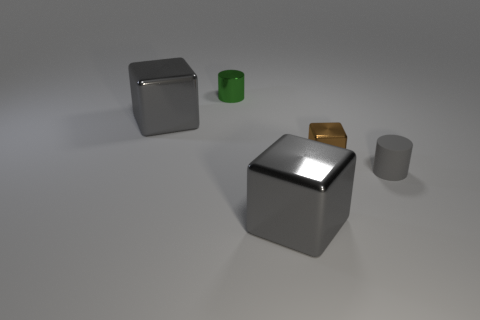Add 5 metallic objects. How many objects exist? 10 Subtract all cubes. How many objects are left? 2 Subtract all tiny green objects. Subtract all green cylinders. How many objects are left? 3 Add 2 small green things. How many small green things are left? 3 Add 3 tiny matte objects. How many tiny matte objects exist? 4 Subtract 0 blue spheres. How many objects are left? 5 